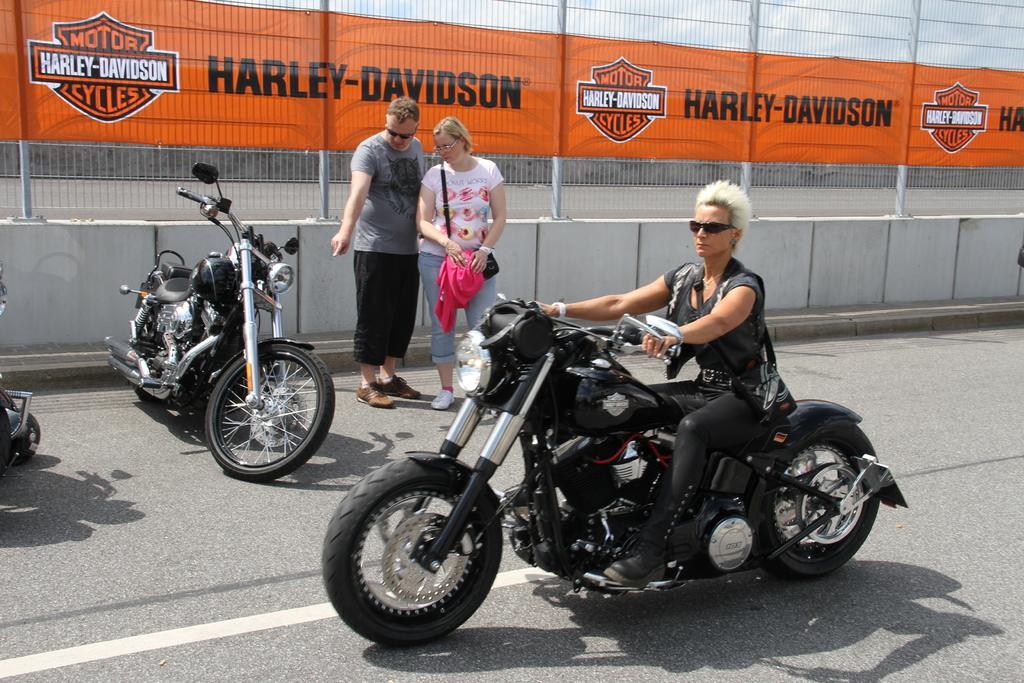How many people are in the image? There are three persons in the image. What are two of the persons doing in the image? Two of the persons are standing on the road. What is the third person doing in the image? One person is riding a motorcycle. What can be seen in the background of the image? There is a fence visible in the background of the image. What type of cart is being pulled by the motorcycle in the image? There is no cart being pulled by the motorcycle in the image. What color is the ink used to write on the fence in the image? There is no ink or writing on the fence in the image. 